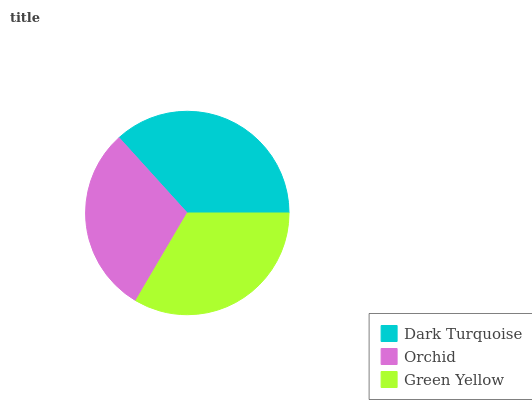Is Orchid the minimum?
Answer yes or no. Yes. Is Dark Turquoise the maximum?
Answer yes or no. Yes. Is Green Yellow the minimum?
Answer yes or no. No. Is Green Yellow the maximum?
Answer yes or no. No. Is Green Yellow greater than Orchid?
Answer yes or no. Yes. Is Orchid less than Green Yellow?
Answer yes or no. Yes. Is Orchid greater than Green Yellow?
Answer yes or no. No. Is Green Yellow less than Orchid?
Answer yes or no. No. Is Green Yellow the high median?
Answer yes or no. Yes. Is Green Yellow the low median?
Answer yes or no. Yes. Is Dark Turquoise the high median?
Answer yes or no. No. Is Dark Turquoise the low median?
Answer yes or no. No. 